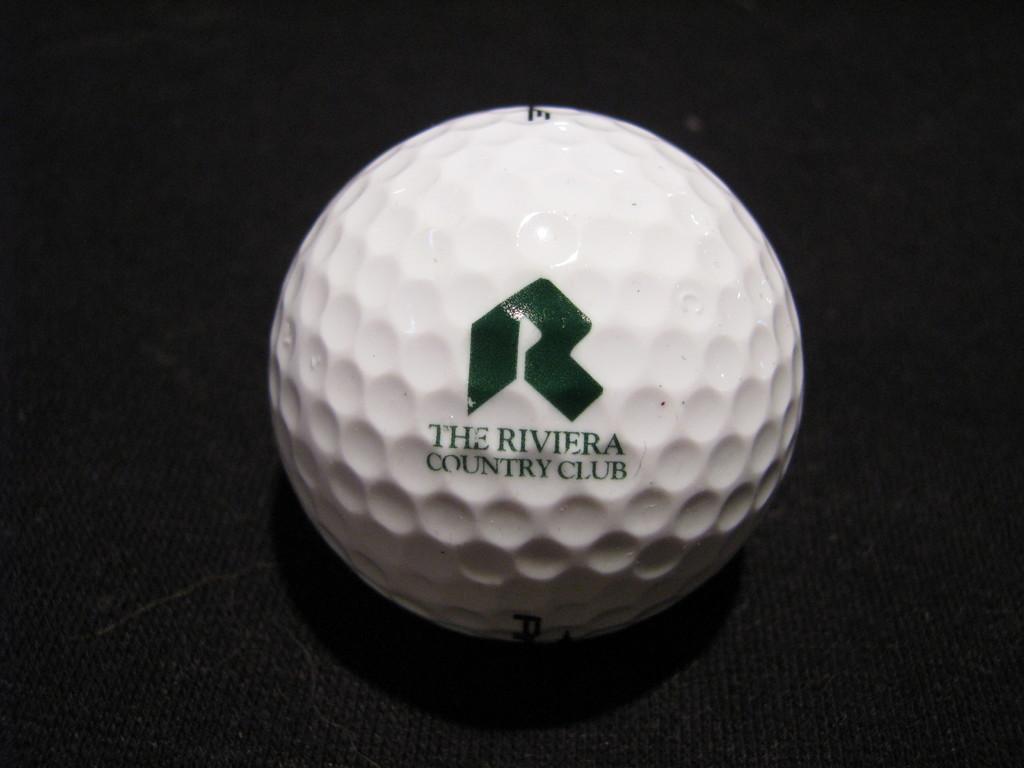How would you summarize this image in a sentence or two? In the image,there is a white ball and the background of the ball is black. 